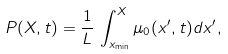Convert formula to latex. <formula><loc_0><loc_0><loc_500><loc_500>P ( X , t ) = \frac { 1 } { L } \, \int _ { x _ { \min } } ^ { X } \mu _ { 0 } ( x ^ { \prime } , t ) d x ^ { \prime } ,</formula> 